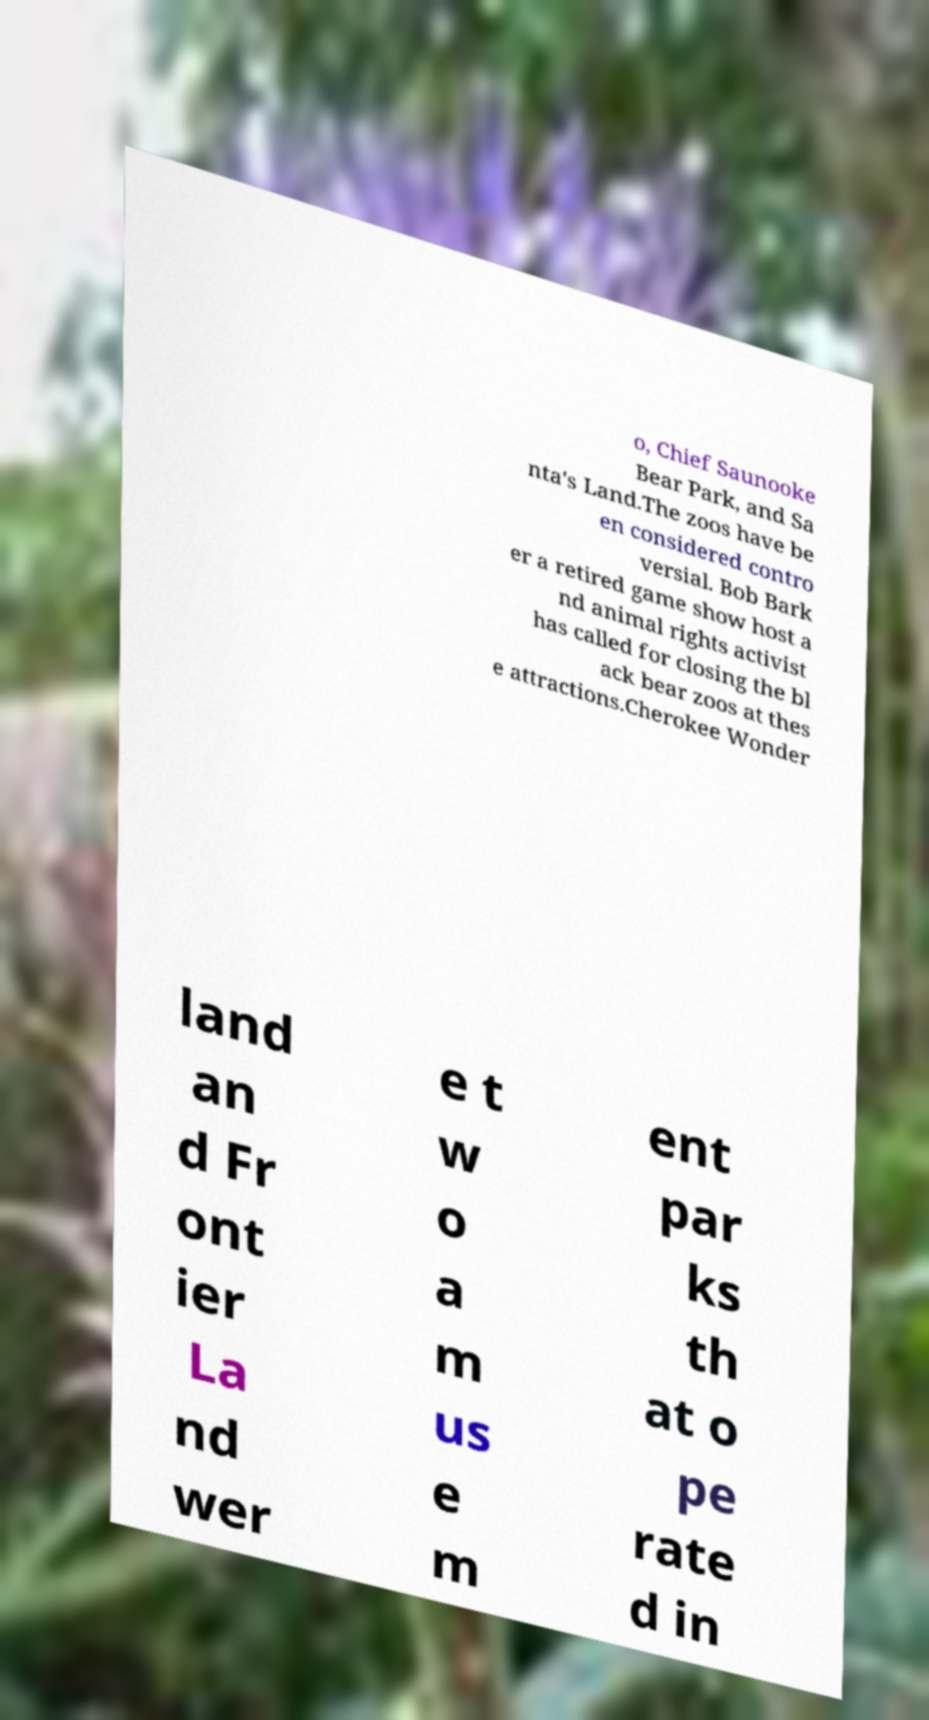For documentation purposes, I need the text within this image transcribed. Could you provide that? o, Chief Saunooke Bear Park, and Sa nta's Land.The zoos have be en considered contro versial. Bob Bark er a retired game show host a nd animal rights activist has called for closing the bl ack bear zoos at thes e attractions.Cherokee Wonder land an d Fr ont ier La nd wer e t w o a m us e m ent par ks th at o pe rate d in 